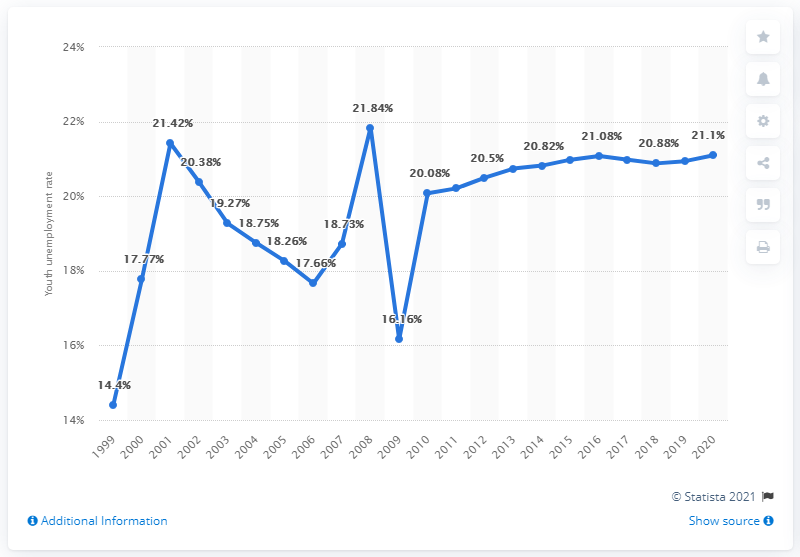Mention a couple of crucial points in this snapshot. In 2020, the youth unemployment rate in Syria was 21.1%. 